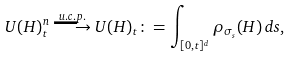<formula> <loc_0><loc_0><loc_500><loc_500>U ( H ) _ { t } ^ { n } \stackrel { u . c . p . } { \longrightarrow } U ( H ) _ { t } \colon = \int _ { [ 0 , t ] ^ { d } } \rho _ { \sigma _ { s } } ( H ) \, d s ,</formula> 